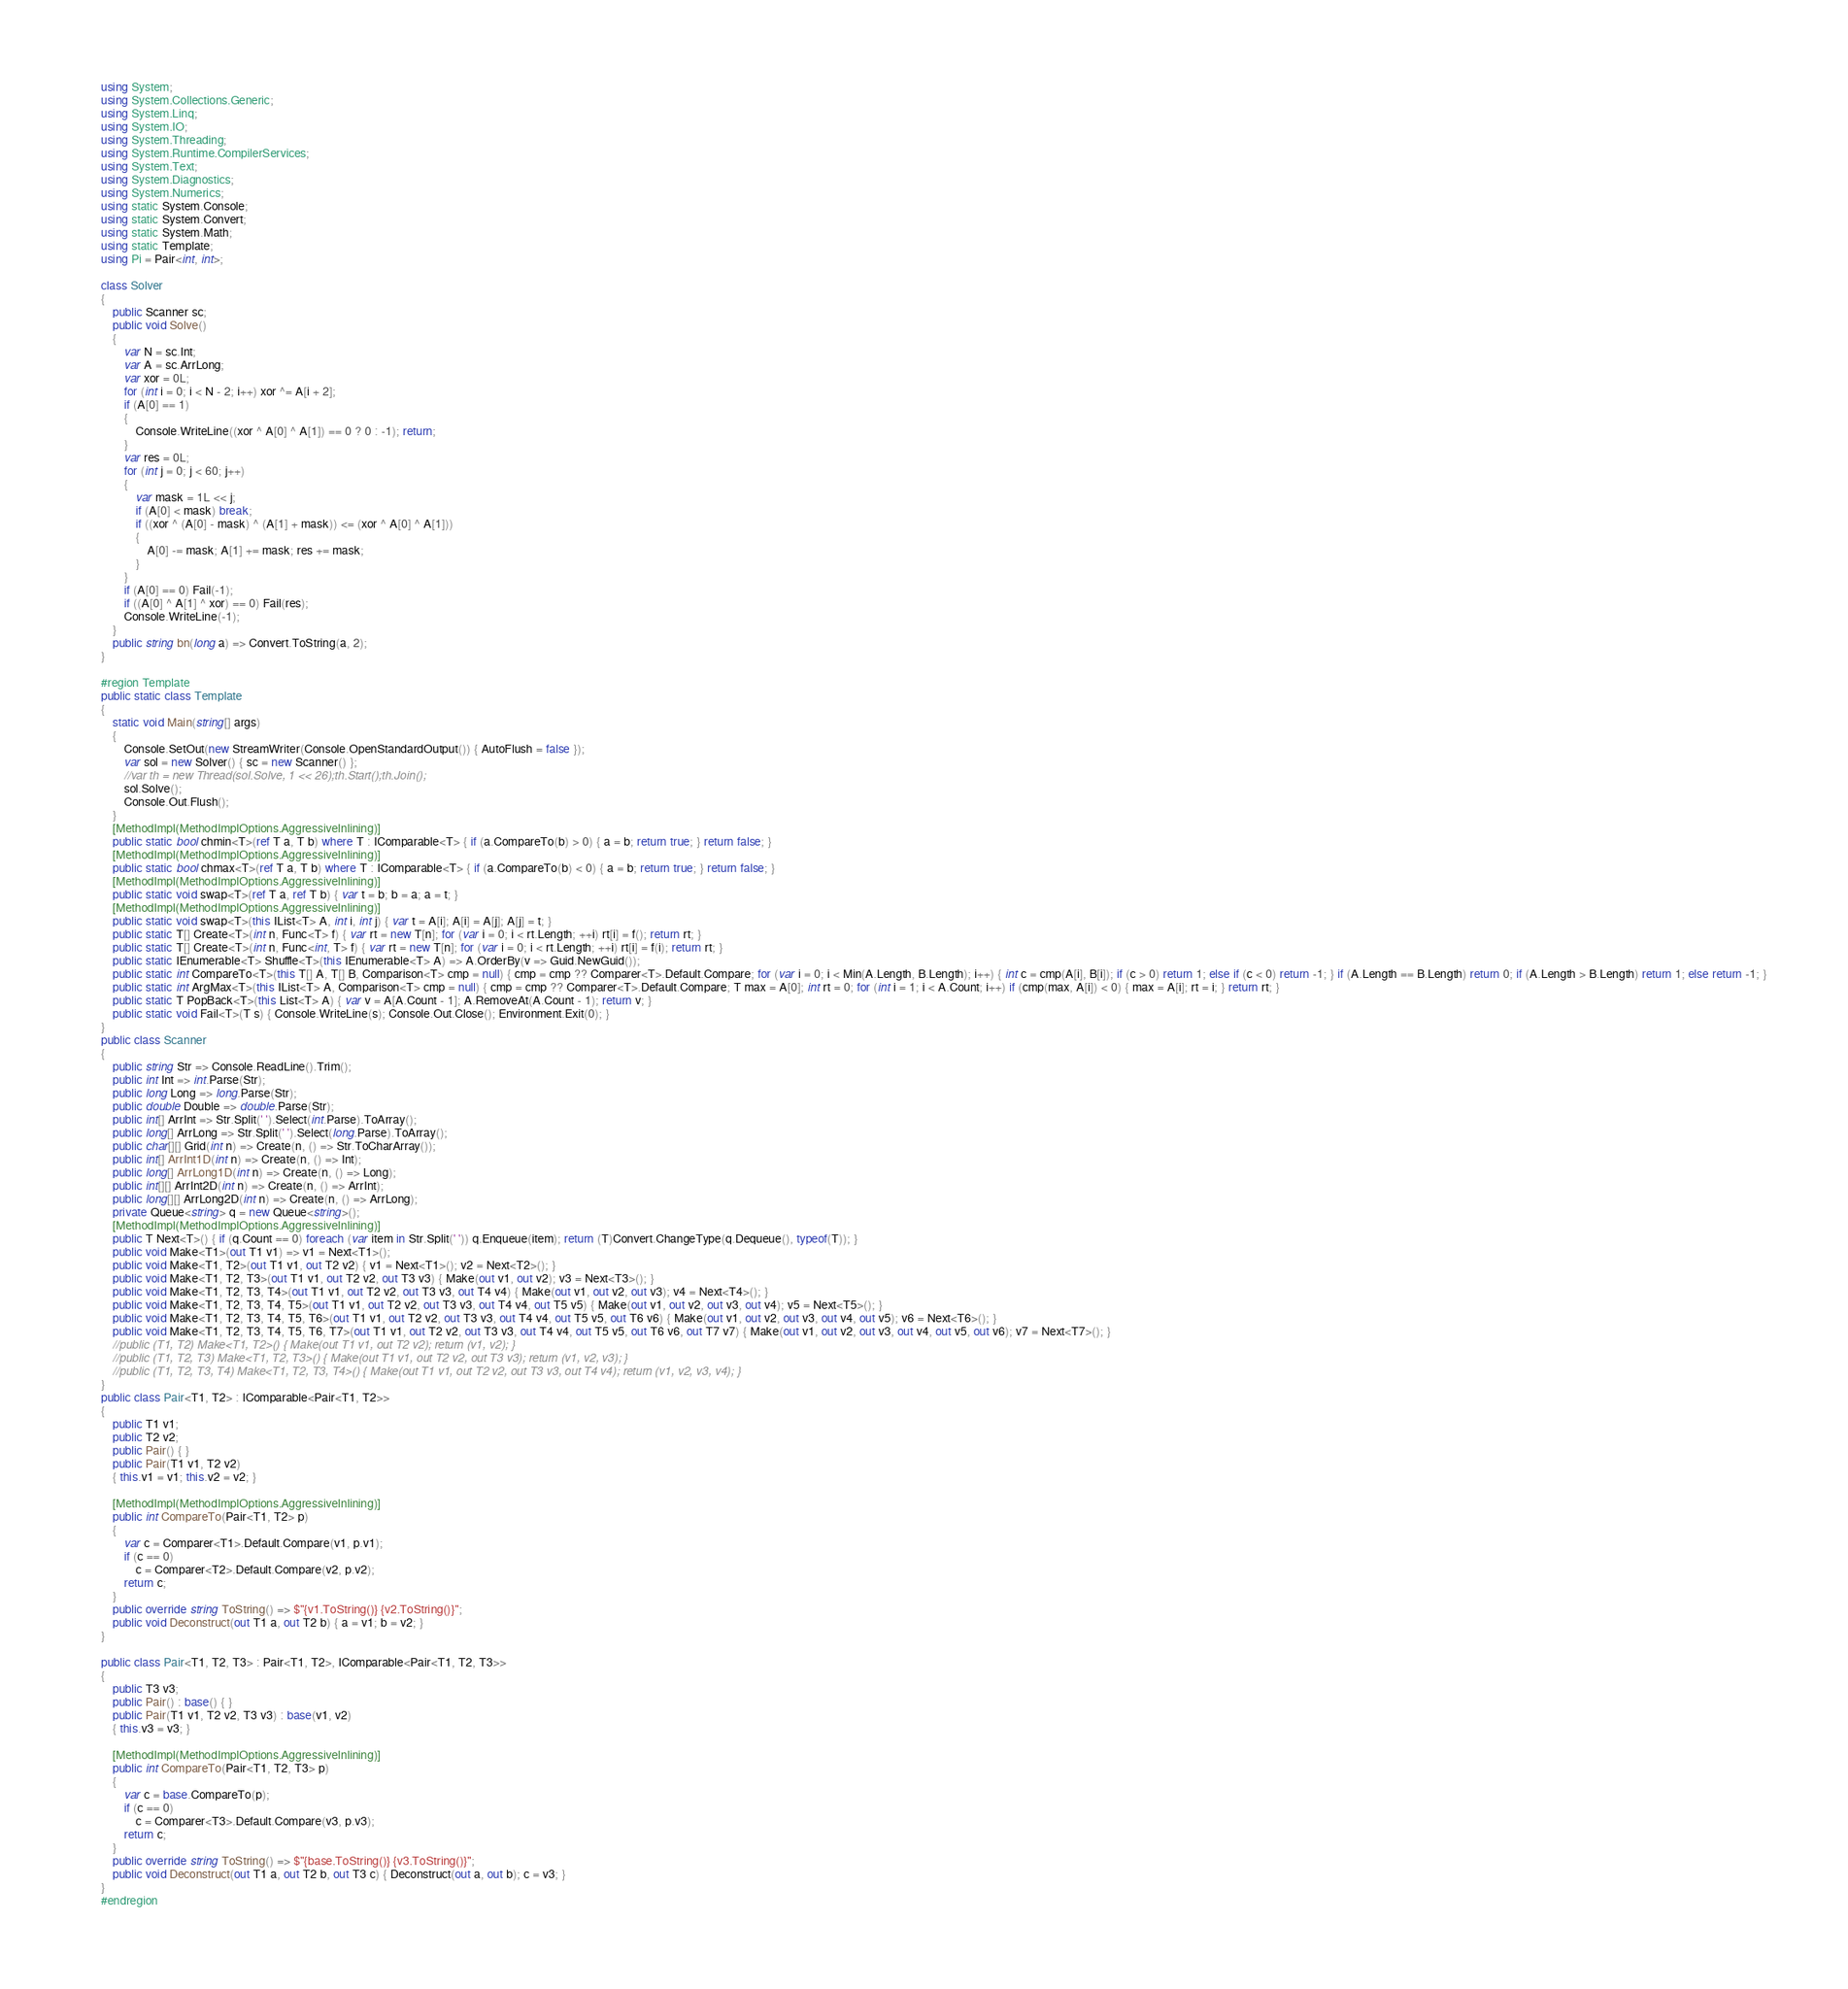<code> <loc_0><loc_0><loc_500><loc_500><_C#_>using System;
using System.Collections.Generic;
using System.Linq;
using System.IO;
using System.Threading;
using System.Runtime.CompilerServices;
using System.Text;
using System.Diagnostics;
using System.Numerics;
using static System.Console;
using static System.Convert;
using static System.Math;
using static Template;
using Pi = Pair<int, int>;

class Solver
{
    public Scanner sc;
    public void Solve()
    {
        var N = sc.Int;
        var A = sc.ArrLong;
        var xor = 0L;
        for (int i = 0; i < N - 2; i++) xor ^= A[i + 2];
        if (A[0] == 1)
        {
            Console.WriteLine((xor ^ A[0] ^ A[1]) == 0 ? 0 : -1); return;
        }
        var res = 0L;
        for (int j = 0; j < 60; j++)
        {
            var mask = 1L << j;
            if (A[0] < mask) break;
            if ((xor ^ (A[0] - mask) ^ (A[1] + mask)) <= (xor ^ A[0] ^ A[1]))
            {
                A[0] -= mask; A[1] += mask; res += mask;
            }
        }
        if (A[0] == 0) Fail(-1);
        if ((A[0] ^ A[1] ^ xor) == 0) Fail(res);
        Console.WriteLine(-1);
    }
    public string bn(long a) => Convert.ToString(a, 2);
}

#region Template
public static class Template
{
    static void Main(string[] args)
    {
        Console.SetOut(new StreamWriter(Console.OpenStandardOutput()) { AutoFlush = false });
        var sol = new Solver() { sc = new Scanner() };
        //var th = new Thread(sol.Solve, 1 << 26);th.Start();th.Join();
        sol.Solve();
        Console.Out.Flush();
    }
    [MethodImpl(MethodImplOptions.AggressiveInlining)]
    public static bool chmin<T>(ref T a, T b) where T : IComparable<T> { if (a.CompareTo(b) > 0) { a = b; return true; } return false; }
    [MethodImpl(MethodImplOptions.AggressiveInlining)]
    public static bool chmax<T>(ref T a, T b) where T : IComparable<T> { if (a.CompareTo(b) < 0) { a = b; return true; } return false; }
    [MethodImpl(MethodImplOptions.AggressiveInlining)]
    public static void swap<T>(ref T a, ref T b) { var t = b; b = a; a = t; }
    [MethodImpl(MethodImplOptions.AggressiveInlining)]
    public static void swap<T>(this IList<T> A, int i, int j) { var t = A[i]; A[i] = A[j]; A[j] = t; }
    public static T[] Create<T>(int n, Func<T> f) { var rt = new T[n]; for (var i = 0; i < rt.Length; ++i) rt[i] = f(); return rt; }
    public static T[] Create<T>(int n, Func<int, T> f) { var rt = new T[n]; for (var i = 0; i < rt.Length; ++i) rt[i] = f(i); return rt; }
    public static IEnumerable<T> Shuffle<T>(this IEnumerable<T> A) => A.OrderBy(v => Guid.NewGuid());
    public static int CompareTo<T>(this T[] A, T[] B, Comparison<T> cmp = null) { cmp = cmp ?? Comparer<T>.Default.Compare; for (var i = 0; i < Min(A.Length, B.Length); i++) { int c = cmp(A[i], B[i]); if (c > 0) return 1; else if (c < 0) return -1; } if (A.Length == B.Length) return 0; if (A.Length > B.Length) return 1; else return -1; }
    public static int ArgMax<T>(this IList<T> A, Comparison<T> cmp = null) { cmp = cmp ?? Comparer<T>.Default.Compare; T max = A[0]; int rt = 0; for (int i = 1; i < A.Count; i++) if (cmp(max, A[i]) < 0) { max = A[i]; rt = i; } return rt; }
    public static T PopBack<T>(this List<T> A) { var v = A[A.Count - 1]; A.RemoveAt(A.Count - 1); return v; }
    public static void Fail<T>(T s) { Console.WriteLine(s); Console.Out.Close(); Environment.Exit(0); }
}
public class Scanner
{
    public string Str => Console.ReadLine().Trim();
    public int Int => int.Parse(Str);
    public long Long => long.Parse(Str);
    public double Double => double.Parse(Str);
    public int[] ArrInt => Str.Split(' ').Select(int.Parse).ToArray();
    public long[] ArrLong => Str.Split(' ').Select(long.Parse).ToArray();
    public char[][] Grid(int n) => Create(n, () => Str.ToCharArray());
    public int[] ArrInt1D(int n) => Create(n, () => Int);
    public long[] ArrLong1D(int n) => Create(n, () => Long);
    public int[][] ArrInt2D(int n) => Create(n, () => ArrInt);
    public long[][] ArrLong2D(int n) => Create(n, () => ArrLong);
    private Queue<string> q = new Queue<string>();
    [MethodImpl(MethodImplOptions.AggressiveInlining)]
    public T Next<T>() { if (q.Count == 0) foreach (var item in Str.Split(' ')) q.Enqueue(item); return (T)Convert.ChangeType(q.Dequeue(), typeof(T)); }
    public void Make<T1>(out T1 v1) => v1 = Next<T1>();
    public void Make<T1, T2>(out T1 v1, out T2 v2) { v1 = Next<T1>(); v2 = Next<T2>(); }
    public void Make<T1, T2, T3>(out T1 v1, out T2 v2, out T3 v3) { Make(out v1, out v2); v3 = Next<T3>(); }
    public void Make<T1, T2, T3, T4>(out T1 v1, out T2 v2, out T3 v3, out T4 v4) { Make(out v1, out v2, out v3); v4 = Next<T4>(); }
    public void Make<T1, T2, T3, T4, T5>(out T1 v1, out T2 v2, out T3 v3, out T4 v4, out T5 v5) { Make(out v1, out v2, out v3, out v4); v5 = Next<T5>(); }
    public void Make<T1, T2, T3, T4, T5, T6>(out T1 v1, out T2 v2, out T3 v3, out T4 v4, out T5 v5, out T6 v6) { Make(out v1, out v2, out v3, out v4, out v5); v6 = Next<T6>(); }
    public void Make<T1, T2, T3, T4, T5, T6, T7>(out T1 v1, out T2 v2, out T3 v3, out T4 v4, out T5 v5, out T6 v6, out T7 v7) { Make(out v1, out v2, out v3, out v4, out v5, out v6); v7 = Next<T7>(); }
    //public (T1, T2) Make<T1, T2>() { Make(out T1 v1, out T2 v2); return (v1, v2); }
    //public (T1, T2, T3) Make<T1, T2, T3>() { Make(out T1 v1, out T2 v2, out T3 v3); return (v1, v2, v3); }
    //public (T1, T2, T3, T4) Make<T1, T2, T3, T4>() { Make(out T1 v1, out T2 v2, out T3 v3, out T4 v4); return (v1, v2, v3, v4); }
}
public class Pair<T1, T2> : IComparable<Pair<T1, T2>>
{
    public T1 v1;
    public T2 v2;
    public Pair() { }
    public Pair(T1 v1, T2 v2)
    { this.v1 = v1; this.v2 = v2; }

    [MethodImpl(MethodImplOptions.AggressiveInlining)]
    public int CompareTo(Pair<T1, T2> p)
    {
        var c = Comparer<T1>.Default.Compare(v1, p.v1);
        if (c == 0)
            c = Comparer<T2>.Default.Compare(v2, p.v2);
        return c;
    }
    public override string ToString() => $"{v1.ToString()} {v2.ToString()}";
    public void Deconstruct(out T1 a, out T2 b) { a = v1; b = v2; }
}

public class Pair<T1, T2, T3> : Pair<T1, T2>, IComparable<Pair<T1, T2, T3>>
{
    public T3 v3;
    public Pair() : base() { }
    public Pair(T1 v1, T2 v2, T3 v3) : base(v1, v2)
    { this.v3 = v3; }

    [MethodImpl(MethodImplOptions.AggressiveInlining)]
    public int CompareTo(Pair<T1, T2, T3> p)
    {
        var c = base.CompareTo(p);
        if (c == 0)
            c = Comparer<T3>.Default.Compare(v3, p.v3);
        return c;
    }
    public override string ToString() => $"{base.ToString()} {v3.ToString()}";
    public void Deconstruct(out T1 a, out T2 b, out T3 c) { Deconstruct(out a, out b); c = v3; }
}
#endregion</code> 